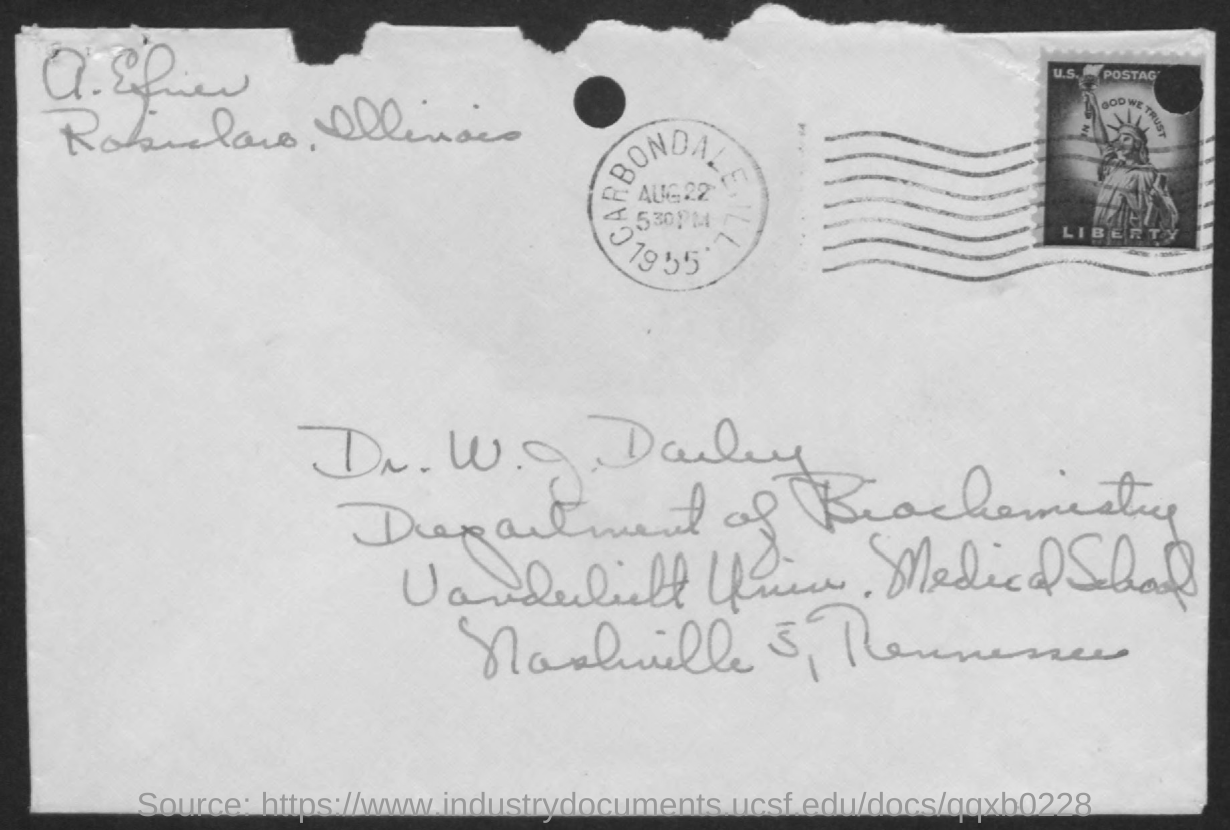What is the date present in the seal?
Make the answer very short. Aug 22. What is written below the image?
Ensure brevity in your answer.  Liberty. What is written above the image?
Provide a succinct answer. In god we trust. Which year is mentioned in the seal?
Your answer should be very brief. 1955. What time is mentioned in the seal?
Your answer should be compact. 5 30 PM. Dr.W.J.Darby belongs to which department?
Your answer should be very brief. Department of Biochemistry. 